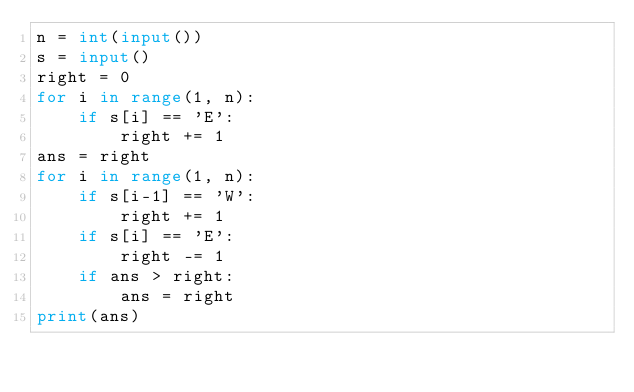<code> <loc_0><loc_0><loc_500><loc_500><_Python_>n = int(input())
s = input()
right = 0
for i in range(1, n):
    if s[i] == 'E':
        right += 1
ans = right
for i in range(1, n):
    if s[i-1] == 'W':
        right += 1
    if s[i] == 'E':
        right -= 1
    if ans > right:
        ans = right
print(ans)
</code> 